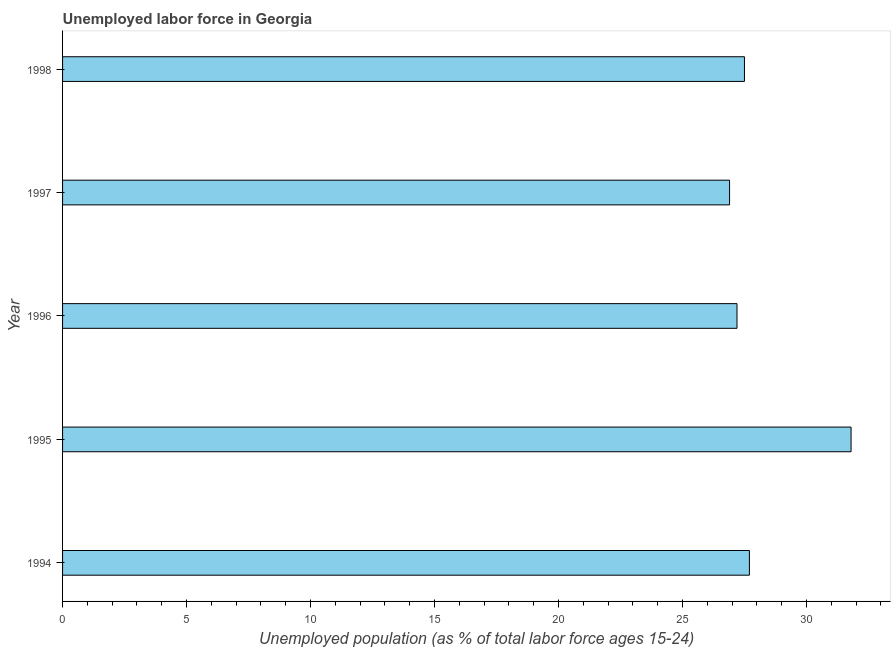Does the graph contain any zero values?
Ensure brevity in your answer.  No. Does the graph contain grids?
Provide a short and direct response. No. What is the title of the graph?
Make the answer very short. Unemployed labor force in Georgia. What is the label or title of the X-axis?
Provide a short and direct response. Unemployed population (as % of total labor force ages 15-24). What is the label or title of the Y-axis?
Offer a terse response. Year. What is the total unemployed youth population in 1996?
Your answer should be compact. 27.2. Across all years, what is the maximum total unemployed youth population?
Offer a terse response. 31.8. Across all years, what is the minimum total unemployed youth population?
Keep it short and to the point. 26.9. In which year was the total unemployed youth population minimum?
Your response must be concise. 1997. What is the sum of the total unemployed youth population?
Your response must be concise. 141.1. What is the average total unemployed youth population per year?
Offer a terse response. 28.22. In how many years, is the total unemployed youth population greater than 17 %?
Give a very brief answer. 5. Is the total unemployed youth population in 1996 less than that in 1997?
Make the answer very short. No. What is the difference between the highest and the second highest total unemployed youth population?
Keep it short and to the point. 4.1. Is the sum of the total unemployed youth population in 1996 and 1998 greater than the maximum total unemployed youth population across all years?
Your response must be concise. Yes. How many bars are there?
Provide a succinct answer. 5. What is the difference between two consecutive major ticks on the X-axis?
Offer a very short reply. 5. Are the values on the major ticks of X-axis written in scientific E-notation?
Your response must be concise. No. What is the Unemployed population (as % of total labor force ages 15-24) of 1994?
Offer a very short reply. 27.7. What is the Unemployed population (as % of total labor force ages 15-24) in 1995?
Provide a succinct answer. 31.8. What is the Unemployed population (as % of total labor force ages 15-24) of 1996?
Offer a terse response. 27.2. What is the Unemployed population (as % of total labor force ages 15-24) in 1997?
Make the answer very short. 26.9. What is the difference between the Unemployed population (as % of total labor force ages 15-24) in 1994 and 1996?
Keep it short and to the point. 0.5. What is the difference between the Unemployed population (as % of total labor force ages 15-24) in 1994 and 1997?
Give a very brief answer. 0.8. What is the difference between the Unemployed population (as % of total labor force ages 15-24) in 1995 and 1997?
Your answer should be compact. 4.9. What is the difference between the Unemployed population (as % of total labor force ages 15-24) in 1995 and 1998?
Your answer should be very brief. 4.3. What is the difference between the Unemployed population (as % of total labor force ages 15-24) in 1997 and 1998?
Offer a very short reply. -0.6. What is the ratio of the Unemployed population (as % of total labor force ages 15-24) in 1994 to that in 1995?
Offer a very short reply. 0.87. What is the ratio of the Unemployed population (as % of total labor force ages 15-24) in 1994 to that in 1997?
Your answer should be very brief. 1.03. What is the ratio of the Unemployed population (as % of total labor force ages 15-24) in 1994 to that in 1998?
Ensure brevity in your answer.  1.01. What is the ratio of the Unemployed population (as % of total labor force ages 15-24) in 1995 to that in 1996?
Keep it short and to the point. 1.17. What is the ratio of the Unemployed population (as % of total labor force ages 15-24) in 1995 to that in 1997?
Offer a terse response. 1.18. What is the ratio of the Unemployed population (as % of total labor force ages 15-24) in 1995 to that in 1998?
Your answer should be compact. 1.16. What is the ratio of the Unemployed population (as % of total labor force ages 15-24) in 1996 to that in 1997?
Make the answer very short. 1.01. 